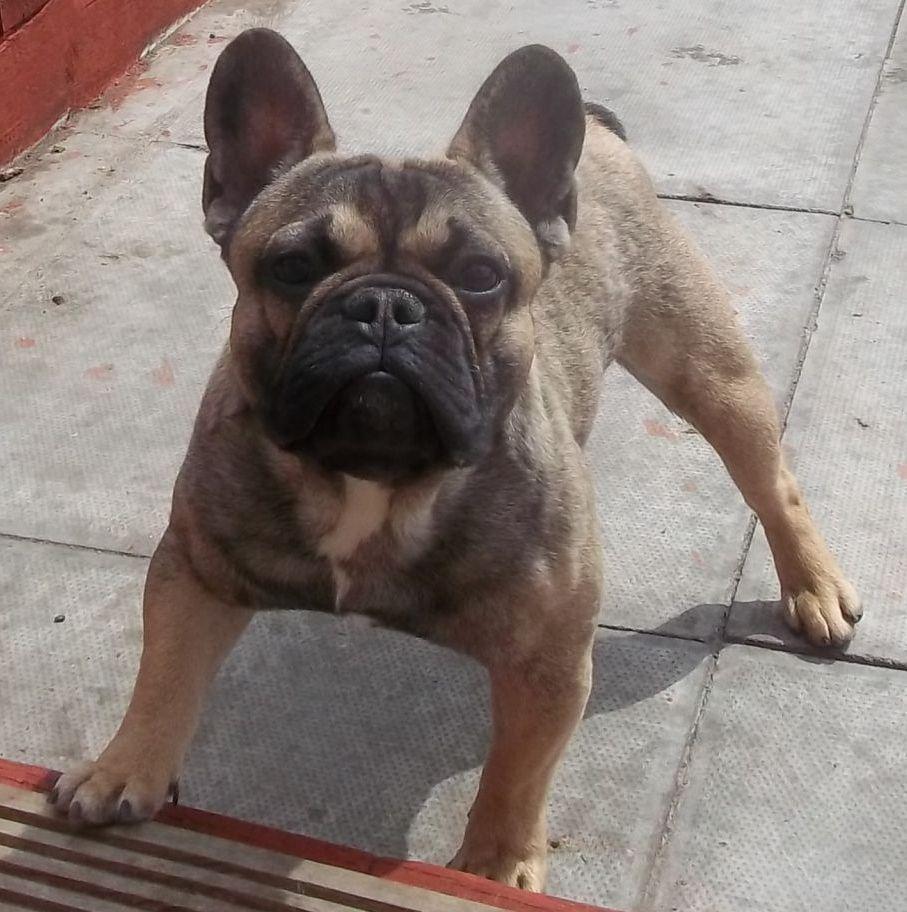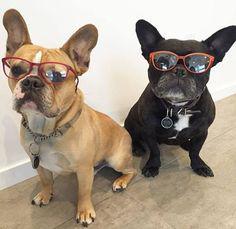The first image is the image on the left, the second image is the image on the right. Assess this claim about the two images: "There are exactly three dogs in total.". Correct or not? Answer yes or no. Yes. 